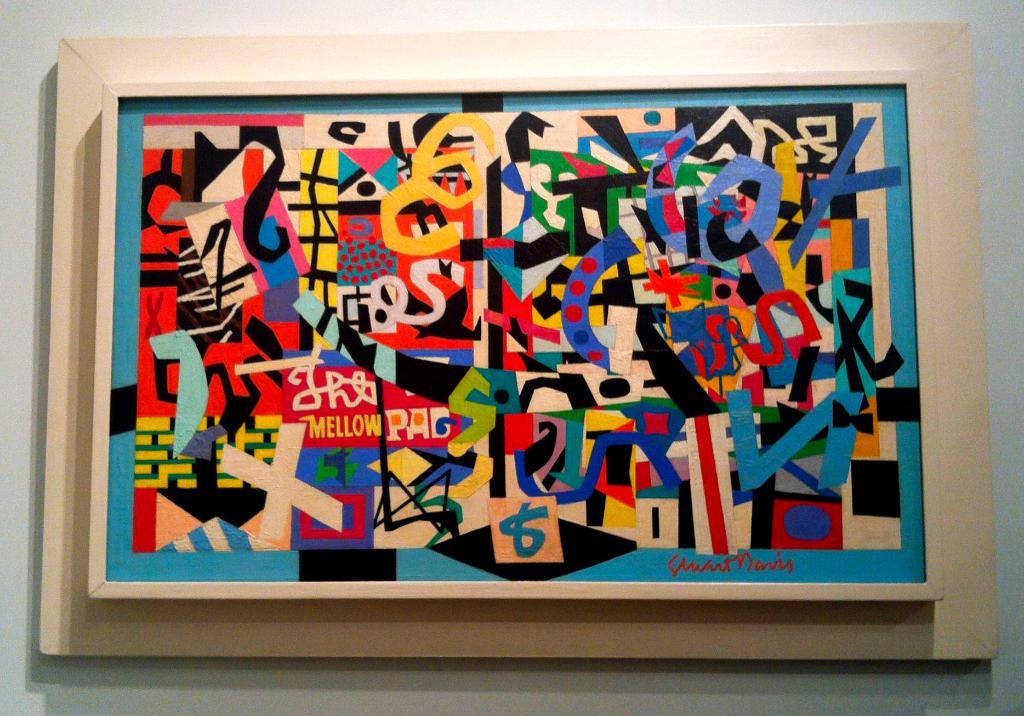What does the yellow work in the middle read?
Make the answer very short. Mellow. 